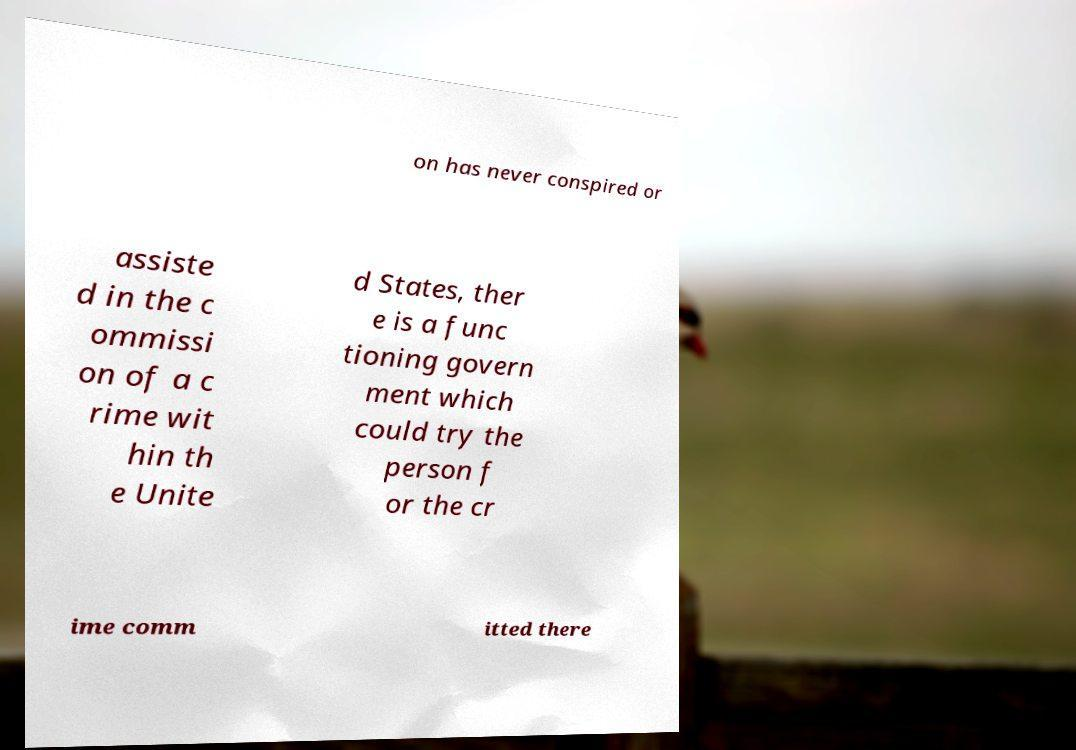Could you extract and type out the text from this image? on has never conspired or assiste d in the c ommissi on of a c rime wit hin th e Unite d States, ther e is a func tioning govern ment which could try the person f or the cr ime comm itted there 